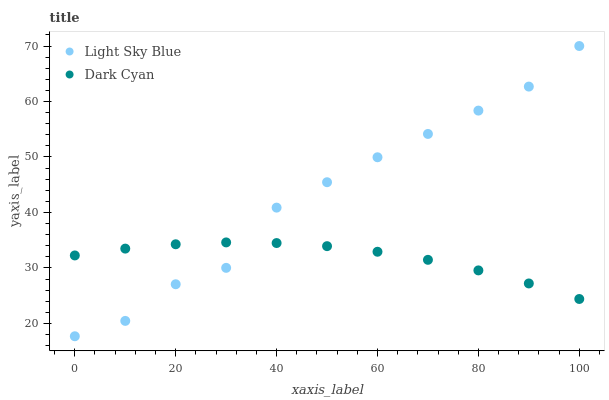Does Dark Cyan have the minimum area under the curve?
Answer yes or no. Yes. Does Light Sky Blue have the maximum area under the curve?
Answer yes or no. Yes. Does Light Sky Blue have the minimum area under the curve?
Answer yes or no. No. Is Dark Cyan the smoothest?
Answer yes or no. Yes. Is Light Sky Blue the roughest?
Answer yes or no. Yes. Is Light Sky Blue the smoothest?
Answer yes or no. No. Does Light Sky Blue have the lowest value?
Answer yes or no. Yes. Does Light Sky Blue have the highest value?
Answer yes or no. Yes. Does Dark Cyan intersect Light Sky Blue?
Answer yes or no. Yes. Is Dark Cyan less than Light Sky Blue?
Answer yes or no. No. Is Dark Cyan greater than Light Sky Blue?
Answer yes or no. No. 